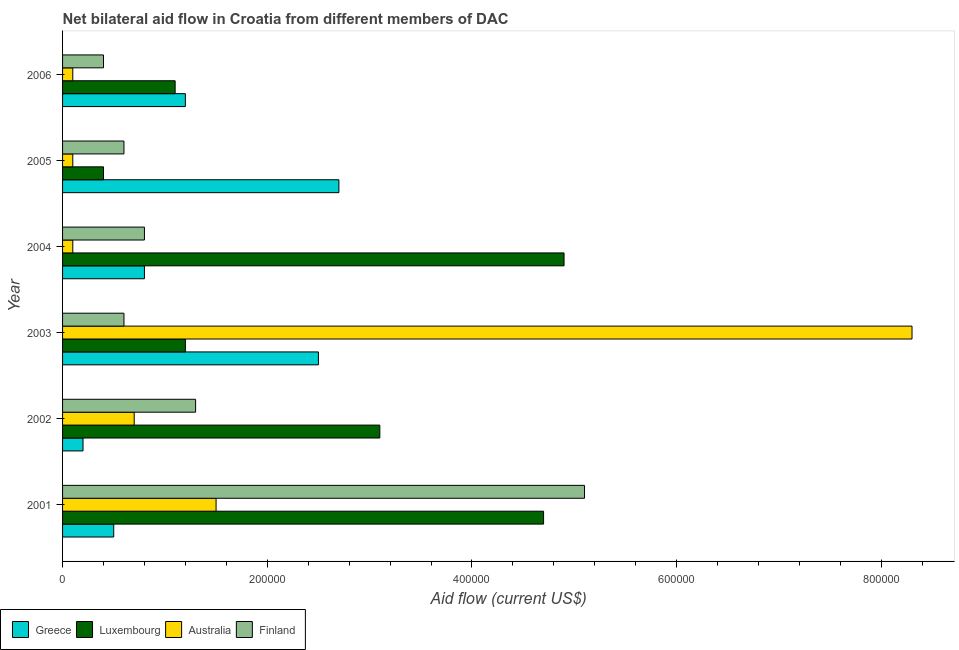Are the number of bars per tick equal to the number of legend labels?
Keep it short and to the point. Yes. Are the number of bars on each tick of the Y-axis equal?
Your answer should be very brief. Yes. How many bars are there on the 3rd tick from the top?
Give a very brief answer. 4. How many bars are there on the 5th tick from the bottom?
Your response must be concise. 4. What is the label of the 6th group of bars from the top?
Your answer should be compact. 2001. In how many cases, is the number of bars for a given year not equal to the number of legend labels?
Make the answer very short. 0. What is the amount of aid given by greece in 2005?
Ensure brevity in your answer.  2.70e+05. Across all years, what is the maximum amount of aid given by australia?
Give a very brief answer. 8.30e+05. Across all years, what is the minimum amount of aid given by australia?
Give a very brief answer. 10000. In which year was the amount of aid given by australia minimum?
Ensure brevity in your answer.  2004. What is the total amount of aid given by finland in the graph?
Your response must be concise. 8.80e+05. What is the difference between the amount of aid given by luxembourg in 2001 and that in 2005?
Provide a succinct answer. 4.30e+05. What is the average amount of aid given by greece per year?
Provide a succinct answer. 1.32e+05. In the year 2003, what is the difference between the amount of aid given by greece and amount of aid given by australia?
Provide a succinct answer. -5.80e+05. Is the difference between the amount of aid given by australia in 2003 and 2004 greater than the difference between the amount of aid given by finland in 2003 and 2004?
Provide a short and direct response. Yes. What is the difference between the highest and the second highest amount of aid given by finland?
Your response must be concise. 3.80e+05. What is the difference between the highest and the lowest amount of aid given by australia?
Provide a succinct answer. 8.20e+05. In how many years, is the amount of aid given by greece greater than the average amount of aid given by greece taken over all years?
Your answer should be compact. 2. Is it the case that in every year, the sum of the amount of aid given by australia and amount of aid given by greece is greater than the sum of amount of aid given by luxembourg and amount of aid given by finland?
Give a very brief answer. No. What does the 4th bar from the bottom in 2006 represents?
Keep it short and to the point. Finland. Is it the case that in every year, the sum of the amount of aid given by greece and amount of aid given by luxembourg is greater than the amount of aid given by australia?
Make the answer very short. No. How many years are there in the graph?
Offer a very short reply. 6. Does the graph contain any zero values?
Keep it short and to the point. No. Does the graph contain grids?
Your answer should be compact. No. How are the legend labels stacked?
Provide a short and direct response. Horizontal. What is the title of the graph?
Provide a short and direct response. Net bilateral aid flow in Croatia from different members of DAC. Does "Other greenhouse gases" appear as one of the legend labels in the graph?
Your response must be concise. No. What is the label or title of the X-axis?
Provide a short and direct response. Aid flow (current US$). What is the Aid flow (current US$) in Greece in 2001?
Give a very brief answer. 5.00e+04. What is the Aid flow (current US$) of Luxembourg in 2001?
Your answer should be very brief. 4.70e+05. What is the Aid flow (current US$) in Finland in 2001?
Your response must be concise. 5.10e+05. What is the Aid flow (current US$) in Greece in 2002?
Your answer should be very brief. 2.00e+04. What is the Aid flow (current US$) of Luxembourg in 2002?
Your answer should be very brief. 3.10e+05. What is the Aid flow (current US$) of Greece in 2003?
Keep it short and to the point. 2.50e+05. What is the Aid flow (current US$) of Luxembourg in 2003?
Offer a terse response. 1.20e+05. What is the Aid flow (current US$) in Australia in 2003?
Give a very brief answer. 8.30e+05. What is the Aid flow (current US$) of Finland in 2003?
Your answer should be very brief. 6.00e+04. What is the Aid flow (current US$) in Australia in 2004?
Provide a short and direct response. 10000. What is the Aid flow (current US$) in Greece in 2005?
Your response must be concise. 2.70e+05. What is the Aid flow (current US$) of Australia in 2005?
Offer a terse response. 10000. What is the Aid flow (current US$) of Greece in 2006?
Your response must be concise. 1.20e+05. What is the Aid flow (current US$) in Luxembourg in 2006?
Your response must be concise. 1.10e+05. Across all years, what is the maximum Aid flow (current US$) of Australia?
Make the answer very short. 8.30e+05. Across all years, what is the maximum Aid flow (current US$) of Finland?
Ensure brevity in your answer.  5.10e+05. Across all years, what is the minimum Aid flow (current US$) in Greece?
Your answer should be very brief. 2.00e+04. Across all years, what is the minimum Aid flow (current US$) of Luxembourg?
Your answer should be compact. 4.00e+04. Across all years, what is the minimum Aid flow (current US$) of Finland?
Your answer should be very brief. 4.00e+04. What is the total Aid flow (current US$) in Greece in the graph?
Give a very brief answer. 7.90e+05. What is the total Aid flow (current US$) of Luxembourg in the graph?
Make the answer very short. 1.54e+06. What is the total Aid flow (current US$) in Australia in the graph?
Offer a terse response. 1.08e+06. What is the total Aid flow (current US$) in Finland in the graph?
Provide a succinct answer. 8.80e+05. What is the difference between the Aid flow (current US$) of Finland in 2001 and that in 2002?
Keep it short and to the point. 3.80e+05. What is the difference between the Aid flow (current US$) in Greece in 2001 and that in 2003?
Your answer should be very brief. -2.00e+05. What is the difference between the Aid flow (current US$) of Australia in 2001 and that in 2003?
Provide a succinct answer. -6.80e+05. What is the difference between the Aid flow (current US$) of Greece in 2001 and that in 2004?
Keep it short and to the point. -3.00e+04. What is the difference between the Aid flow (current US$) of Luxembourg in 2001 and that in 2004?
Ensure brevity in your answer.  -2.00e+04. What is the difference between the Aid flow (current US$) in Finland in 2001 and that in 2004?
Provide a succinct answer. 4.30e+05. What is the difference between the Aid flow (current US$) in Greece in 2001 and that in 2005?
Your answer should be very brief. -2.20e+05. What is the difference between the Aid flow (current US$) of Luxembourg in 2001 and that in 2006?
Offer a terse response. 3.60e+05. What is the difference between the Aid flow (current US$) of Australia in 2001 and that in 2006?
Make the answer very short. 1.40e+05. What is the difference between the Aid flow (current US$) in Finland in 2001 and that in 2006?
Provide a short and direct response. 4.70e+05. What is the difference between the Aid flow (current US$) of Australia in 2002 and that in 2003?
Provide a succinct answer. -7.60e+05. What is the difference between the Aid flow (current US$) in Finland in 2002 and that in 2003?
Offer a very short reply. 7.00e+04. What is the difference between the Aid flow (current US$) of Greece in 2002 and that in 2004?
Offer a very short reply. -6.00e+04. What is the difference between the Aid flow (current US$) of Luxembourg in 2002 and that in 2004?
Your answer should be compact. -1.80e+05. What is the difference between the Aid flow (current US$) in Australia in 2002 and that in 2004?
Your answer should be very brief. 6.00e+04. What is the difference between the Aid flow (current US$) of Finland in 2002 and that in 2004?
Offer a very short reply. 5.00e+04. What is the difference between the Aid flow (current US$) of Greece in 2002 and that in 2005?
Offer a very short reply. -2.50e+05. What is the difference between the Aid flow (current US$) in Luxembourg in 2002 and that in 2005?
Keep it short and to the point. 2.70e+05. What is the difference between the Aid flow (current US$) of Australia in 2002 and that in 2005?
Ensure brevity in your answer.  6.00e+04. What is the difference between the Aid flow (current US$) in Finland in 2002 and that in 2005?
Your answer should be compact. 7.00e+04. What is the difference between the Aid flow (current US$) in Finland in 2002 and that in 2006?
Ensure brevity in your answer.  9.00e+04. What is the difference between the Aid flow (current US$) in Luxembourg in 2003 and that in 2004?
Give a very brief answer. -3.70e+05. What is the difference between the Aid flow (current US$) in Australia in 2003 and that in 2004?
Keep it short and to the point. 8.20e+05. What is the difference between the Aid flow (current US$) in Greece in 2003 and that in 2005?
Make the answer very short. -2.00e+04. What is the difference between the Aid flow (current US$) of Australia in 2003 and that in 2005?
Provide a succinct answer. 8.20e+05. What is the difference between the Aid flow (current US$) of Australia in 2003 and that in 2006?
Offer a terse response. 8.20e+05. What is the difference between the Aid flow (current US$) of Finland in 2003 and that in 2006?
Keep it short and to the point. 2.00e+04. What is the difference between the Aid flow (current US$) of Australia in 2004 and that in 2005?
Your answer should be very brief. 0. What is the difference between the Aid flow (current US$) of Finland in 2004 and that in 2006?
Your answer should be compact. 4.00e+04. What is the difference between the Aid flow (current US$) in Greece in 2005 and that in 2006?
Offer a terse response. 1.50e+05. What is the difference between the Aid flow (current US$) in Finland in 2005 and that in 2006?
Give a very brief answer. 2.00e+04. What is the difference between the Aid flow (current US$) of Greece in 2001 and the Aid flow (current US$) of Luxembourg in 2002?
Provide a short and direct response. -2.60e+05. What is the difference between the Aid flow (current US$) of Greece in 2001 and the Aid flow (current US$) of Australia in 2002?
Keep it short and to the point. -2.00e+04. What is the difference between the Aid flow (current US$) in Greece in 2001 and the Aid flow (current US$) in Finland in 2002?
Offer a terse response. -8.00e+04. What is the difference between the Aid flow (current US$) of Luxembourg in 2001 and the Aid flow (current US$) of Australia in 2002?
Ensure brevity in your answer.  4.00e+05. What is the difference between the Aid flow (current US$) in Greece in 2001 and the Aid flow (current US$) in Luxembourg in 2003?
Keep it short and to the point. -7.00e+04. What is the difference between the Aid flow (current US$) in Greece in 2001 and the Aid flow (current US$) in Australia in 2003?
Offer a terse response. -7.80e+05. What is the difference between the Aid flow (current US$) of Luxembourg in 2001 and the Aid flow (current US$) of Australia in 2003?
Keep it short and to the point. -3.60e+05. What is the difference between the Aid flow (current US$) of Luxembourg in 2001 and the Aid flow (current US$) of Finland in 2003?
Give a very brief answer. 4.10e+05. What is the difference between the Aid flow (current US$) of Greece in 2001 and the Aid flow (current US$) of Luxembourg in 2004?
Offer a very short reply. -4.40e+05. What is the difference between the Aid flow (current US$) in Luxembourg in 2001 and the Aid flow (current US$) in Australia in 2004?
Your response must be concise. 4.60e+05. What is the difference between the Aid flow (current US$) in Greece in 2001 and the Aid flow (current US$) in Finland in 2005?
Offer a very short reply. -10000. What is the difference between the Aid flow (current US$) in Australia in 2001 and the Aid flow (current US$) in Finland in 2005?
Provide a succinct answer. 9.00e+04. What is the difference between the Aid flow (current US$) of Luxembourg in 2001 and the Aid flow (current US$) of Australia in 2006?
Provide a succinct answer. 4.60e+05. What is the difference between the Aid flow (current US$) in Australia in 2001 and the Aid flow (current US$) in Finland in 2006?
Keep it short and to the point. 1.10e+05. What is the difference between the Aid flow (current US$) of Greece in 2002 and the Aid flow (current US$) of Australia in 2003?
Ensure brevity in your answer.  -8.10e+05. What is the difference between the Aid flow (current US$) in Luxembourg in 2002 and the Aid flow (current US$) in Australia in 2003?
Give a very brief answer. -5.20e+05. What is the difference between the Aid flow (current US$) of Luxembourg in 2002 and the Aid flow (current US$) of Finland in 2003?
Offer a terse response. 2.50e+05. What is the difference between the Aid flow (current US$) in Australia in 2002 and the Aid flow (current US$) in Finland in 2003?
Your response must be concise. 10000. What is the difference between the Aid flow (current US$) in Greece in 2002 and the Aid flow (current US$) in Luxembourg in 2004?
Your answer should be very brief. -4.70e+05. What is the difference between the Aid flow (current US$) in Luxembourg in 2002 and the Aid flow (current US$) in Australia in 2004?
Give a very brief answer. 3.00e+05. What is the difference between the Aid flow (current US$) of Luxembourg in 2002 and the Aid flow (current US$) of Finland in 2004?
Your answer should be very brief. 2.30e+05. What is the difference between the Aid flow (current US$) in Luxembourg in 2002 and the Aid flow (current US$) in Australia in 2005?
Your answer should be very brief. 3.00e+05. What is the difference between the Aid flow (current US$) of Luxembourg in 2002 and the Aid flow (current US$) of Finland in 2005?
Your response must be concise. 2.50e+05. What is the difference between the Aid flow (current US$) of Greece in 2002 and the Aid flow (current US$) of Australia in 2006?
Provide a succinct answer. 10000. What is the difference between the Aid flow (current US$) in Greece in 2002 and the Aid flow (current US$) in Finland in 2006?
Your answer should be compact. -2.00e+04. What is the difference between the Aid flow (current US$) of Greece in 2003 and the Aid flow (current US$) of Luxembourg in 2004?
Give a very brief answer. -2.40e+05. What is the difference between the Aid flow (current US$) in Luxembourg in 2003 and the Aid flow (current US$) in Australia in 2004?
Your answer should be compact. 1.10e+05. What is the difference between the Aid flow (current US$) in Australia in 2003 and the Aid flow (current US$) in Finland in 2004?
Provide a short and direct response. 7.50e+05. What is the difference between the Aid flow (current US$) in Greece in 2003 and the Aid flow (current US$) in Luxembourg in 2005?
Ensure brevity in your answer.  2.10e+05. What is the difference between the Aid flow (current US$) in Greece in 2003 and the Aid flow (current US$) in Finland in 2005?
Keep it short and to the point. 1.90e+05. What is the difference between the Aid flow (current US$) of Luxembourg in 2003 and the Aid flow (current US$) of Finland in 2005?
Give a very brief answer. 6.00e+04. What is the difference between the Aid flow (current US$) of Australia in 2003 and the Aid flow (current US$) of Finland in 2005?
Give a very brief answer. 7.70e+05. What is the difference between the Aid flow (current US$) in Greece in 2003 and the Aid flow (current US$) in Luxembourg in 2006?
Ensure brevity in your answer.  1.40e+05. What is the difference between the Aid flow (current US$) of Greece in 2003 and the Aid flow (current US$) of Australia in 2006?
Ensure brevity in your answer.  2.40e+05. What is the difference between the Aid flow (current US$) of Luxembourg in 2003 and the Aid flow (current US$) of Australia in 2006?
Ensure brevity in your answer.  1.10e+05. What is the difference between the Aid flow (current US$) in Luxembourg in 2003 and the Aid flow (current US$) in Finland in 2006?
Keep it short and to the point. 8.00e+04. What is the difference between the Aid flow (current US$) of Australia in 2003 and the Aid flow (current US$) of Finland in 2006?
Provide a short and direct response. 7.90e+05. What is the difference between the Aid flow (current US$) of Greece in 2004 and the Aid flow (current US$) of Luxembourg in 2005?
Your response must be concise. 4.00e+04. What is the difference between the Aid flow (current US$) in Greece in 2004 and the Aid flow (current US$) in Australia in 2005?
Keep it short and to the point. 7.00e+04. What is the difference between the Aid flow (current US$) of Greece in 2004 and the Aid flow (current US$) of Finland in 2005?
Give a very brief answer. 2.00e+04. What is the difference between the Aid flow (current US$) of Luxembourg in 2004 and the Aid flow (current US$) of Australia in 2005?
Keep it short and to the point. 4.80e+05. What is the difference between the Aid flow (current US$) of Greece in 2004 and the Aid flow (current US$) of Luxembourg in 2006?
Your answer should be compact. -3.00e+04. What is the difference between the Aid flow (current US$) in Greece in 2004 and the Aid flow (current US$) in Australia in 2006?
Offer a very short reply. 7.00e+04. What is the difference between the Aid flow (current US$) of Luxembourg in 2004 and the Aid flow (current US$) of Finland in 2006?
Offer a very short reply. 4.50e+05. What is the difference between the Aid flow (current US$) of Australia in 2004 and the Aid flow (current US$) of Finland in 2006?
Offer a very short reply. -3.00e+04. What is the difference between the Aid flow (current US$) of Greece in 2005 and the Aid flow (current US$) of Australia in 2006?
Provide a succinct answer. 2.60e+05. What is the difference between the Aid flow (current US$) in Luxembourg in 2005 and the Aid flow (current US$) in Australia in 2006?
Keep it short and to the point. 3.00e+04. What is the average Aid flow (current US$) of Greece per year?
Your answer should be compact. 1.32e+05. What is the average Aid flow (current US$) in Luxembourg per year?
Offer a terse response. 2.57e+05. What is the average Aid flow (current US$) in Australia per year?
Your response must be concise. 1.80e+05. What is the average Aid flow (current US$) of Finland per year?
Keep it short and to the point. 1.47e+05. In the year 2001, what is the difference between the Aid flow (current US$) of Greece and Aid flow (current US$) of Luxembourg?
Keep it short and to the point. -4.20e+05. In the year 2001, what is the difference between the Aid flow (current US$) of Greece and Aid flow (current US$) of Australia?
Your answer should be compact. -1.00e+05. In the year 2001, what is the difference between the Aid flow (current US$) in Greece and Aid flow (current US$) in Finland?
Provide a succinct answer. -4.60e+05. In the year 2001, what is the difference between the Aid flow (current US$) of Luxembourg and Aid flow (current US$) of Australia?
Your answer should be very brief. 3.20e+05. In the year 2001, what is the difference between the Aid flow (current US$) of Luxembourg and Aid flow (current US$) of Finland?
Ensure brevity in your answer.  -4.00e+04. In the year 2001, what is the difference between the Aid flow (current US$) in Australia and Aid flow (current US$) in Finland?
Provide a short and direct response. -3.60e+05. In the year 2002, what is the difference between the Aid flow (current US$) of Greece and Aid flow (current US$) of Australia?
Offer a very short reply. -5.00e+04. In the year 2002, what is the difference between the Aid flow (current US$) in Luxembourg and Aid flow (current US$) in Australia?
Provide a succinct answer. 2.40e+05. In the year 2003, what is the difference between the Aid flow (current US$) in Greece and Aid flow (current US$) in Luxembourg?
Your answer should be very brief. 1.30e+05. In the year 2003, what is the difference between the Aid flow (current US$) of Greece and Aid flow (current US$) of Australia?
Offer a very short reply. -5.80e+05. In the year 2003, what is the difference between the Aid flow (current US$) in Luxembourg and Aid flow (current US$) in Australia?
Provide a short and direct response. -7.10e+05. In the year 2003, what is the difference between the Aid flow (current US$) in Australia and Aid flow (current US$) in Finland?
Your answer should be compact. 7.70e+05. In the year 2004, what is the difference between the Aid flow (current US$) of Greece and Aid flow (current US$) of Luxembourg?
Your response must be concise. -4.10e+05. In the year 2004, what is the difference between the Aid flow (current US$) of Greece and Aid flow (current US$) of Australia?
Ensure brevity in your answer.  7.00e+04. In the year 2004, what is the difference between the Aid flow (current US$) in Greece and Aid flow (current US$) in Finland?
Provide a succinct answer. 0. In the year 2004, what is the difference between the Aid flow (current US$) in Luxembourg and Aid flow (current US$) in Finland?
Your answer should be compact. 4.10e+05. In the year 2004, what is the difference between the Aid flow (current US$) of Australia and Aid flow (current US$) of Finland?
Ensure brevity in your answer.  -7.00e+04. In the year 2005, what is the difference between the Aid flow (current US$) in Greece and Aid flow (current US$) in Luxembourg?
Give a very brief answer. 2.30e+05. In the year 2005, what is the difference between the Aid flow (current US$) in Greece and Aid flow (current US$) in Australia?
Make the answer very short. 2.60e+05. In the year 2005, what is the difference between the Aid flow (current US$) of Greece and Aid flow (current US$) of Finland?
Your answer should be very brief. 2.10e+05. In the year 2005, what is the difference between the Aid flow (current US$) of Luxembourg and Aid flow (current US$) of Australia?
Your answer should be very brief. 3.00e+04. In the year 2005, what is the difference between the Aid flow (current US$) of Australia and Aid flow (current US$) of Finland?
Keep it short and to the point. -5.00e+04. In the year 2006, what is the difference between the Aid flow (current US$) of Greece and Aid flow (current US$) of Australia?
Offer a very short reply. 1.10e+05. In the year 2006, what is the difference between the Aid flow (current US$) in Greece and Aid flow (current US$) in Finland?
Offer a terse response. 8.00e+04. In the year 2006, what is the difference between the Aid flow (current US$) of Luxembourg and Aid flow (current US$) of Australia?
Give a very brief answer. 1.00e+05. In the year 2006, what is the difference between the Aid flow (current US$) in Luxembourg and Aid flow (current US$) in Finland?
Make the answer very short. 7.00e+04. What is the ratio of the Aid flow (current US$) in Greece in 2001 to that in 2002?
Provide a succinct answer. 2.5. What is the ratio of the Aid flow (current US$) in Luxembourg in 2001 to that in 2002?
Your response must be concise. 1.52. What is the ratio of the Aid flow (current US$) in Australia in 2001 to that in 2002?
Your answer should be very brief. 2.14. What is the ratio of the Aid flow (current US$) of Finland in 2001 to that in 2002?
Give a very brief answer. 3.92. What is the ratio of the Aid flow (current US$) in Luxembourg in 2001 to that in 2003?
Offer a terse response. 3.92. What is the ratio of the Aid flow (current US$) of Australia in 2001 to that in 2003?
Offer a terse response. 0.18. What is the ratio of the Aid flow (current US$) of Greece in 2001 to that in 2004?
Your answer should be very brief. 0.62. What is the ratio of the Aid flow (current US$) in Luxembourg in 2001 to that in 2004?
Make the answer very short. 0.96. What is the ratio of the Aid flow (current US$) in Australia in 2001 to that in 2004?
Ensure brevity in your answer.  15. What is the ratio of the Aid flow (current US$) in Finland in 2001 to that in 2004?
Provide a short and direct response. 6.38. What is the ratio of the Aid flow (current US$) in Greece in 2001 to that in 2005?
Offer a terse response. 0.19. What is the ratio of the Aid flow (current US$) of Luxembourg in 2001 to that in 2005?
Provide a succinct answer. 11.75. What is the ratio of the Aid flow (current US$) in Australia in 2001 to that in 2005?
Your response must be concise. 15. What is the ratio of the Aid flow (current US$) of Greece in 2001 to that in 2006?
Give a very brief answer. 0.42. What is the ratio of the Aid flow (current US$) of Luxembourg in 2001 to that in 2006?
Your answer should be very brief. 4.27. What is the ratio of the Aid flow (current US$) of Australia in 2001 to that in 2006?
Your answer should be compact. 15. What is the ratio of the Aid flow (current US$) of Finland in 2001 to that in 2006?
Your response must be concise. 12.75. What is the ratio of the Aid flow (current US$) in Luxembourg in 2002 to that in 2003?
Make the answer very short. 2.58. What is the ratio of the Aid flow (current US$) of Australia in 2002 to that in 2003?
Give a very brief answer. 0.08. What is the ratio of the Aid flow (current US$) in Finland in 2002 to that in 2003?
Make the answer very short. 2.17. What is the ratio of the Aid flow (current US$) of Luxembourg in 2002 to that in 2004?
Offer a terse response. 0.63. What is the ratio of the Aid flow (current US$) of Finland in 2002 to that in 2004?
Your answer should be very brief. 1.62. What is the ratio of the Aid flow (current US$) in Greece in 2002 to that in 2005?
Your response must be concise. 0.07. What is the ratio of the Aid flow (current US$) of Luxembourg in 2002 to that in 2005?
Offer a terse response. 7.75. What is the ratio of the Aid flow (current US$) of Australia in 2002 to that in 2005?
Your response must be concise. 7. What is the ratio of the Aid flow (current US$) of Finland in 2002 to that in 2005?
Offer a very short reply. 2.17. What is the ratio of the Aid flow (current US$) in Greece in 2002 to that in 2006?
Make the answer very short. 0.17. What is the ratio of the Aid flow (current US$) of Luxembourg in 2002 to that in 2006?
Your response must be concise. 2.82. What is the ratio of the Aid flow (current US$) in Australia in 2002 to that in 2006?
Ensure brevity in your answer.  7. What is the ratio of the Aid flow (current US$) of Greece in 2003 to that in 2004?
Your answer should be very brief. 3.12. What is the ratio of the Aid flow (current US$) of Luxembourg in 2003 to that in 2004?
Give a very brief answer. 0.24. What is the ratio of the Aid flow (current US$) in Finland in 2003 to that in 2004?
Your answer should be compact. 0.75. What is the ratio of the Aid flow (current US$) of Greece in 2003 to that in 2005?
Ensure brevity in your answer.  0.93. What is the ratio of the Aid flow (current US$) of Luxembourg in 2003 to that in 2005?
Give a very brief answer. 3. What is the ratio of the Aid flow (current US$) of Australia in 2003 to that in 2005?
Keep it short and to the point. 83. What is the ratio of the Aid flow (current US$) of Greece in 2003 to that in 2006?
Provide a succinct answer. 2.08. What is the ratio of the Aid flow (current US$) in Australia in 2003 to that in 2006?
Provide a short and direct response. 83. What is the ratio of the Aid flow (current US$) in Greece in 2004 to that in 2005?
Offer a terse response. 0.3. What is the ratio of the Aid flow (current US$) in Luxembourg in 2004 to that in 2005?
Provide a succinct answer. 12.25. What is the ratio of the Aid flow (current US$) of Australia in 2004 to that in 2005?
Your answer should be very brief. 1. What is the ratio of the Aid flow (current US$) of Greece in 2004 to that in 2006?
Provide a succinct answer. 0.67. What is the ratio of the Aid flow (current US$) of Luxembourg in 2004 to that in 2006?
Your answer should be very brief. 4.45. What is the ratio of the Aid flow (current US$) in Greece in 2005 to that in 2006?
Make the answer very short. 2.25. What is the ratio of the Aid flow (current US$) in Luxembourg in 2005 to that in 2006?
Your response must be concise. 0.36. What is the difference between the highest and the second highest Aid flow (current US$) in Australia?
Keep it short and to the point. 6.80e+05. What is the difference between the highest and the second highest Aid flow (current US$) of Finland?
Your answer should be compact. 3.80e+05. What is the difference between the highest and the lowest Aid flow (current US$) in Greece?
Provide a short and direct response. 2.50e+05. What is the difference between the highest and the lowest Aid flow (current US$) of Australia?
Ensure brevity in your answer.  8.20e+05. What is the difference between the highest and the lowest Aid flow (current US$) of Finland?
Make the answer very short. 4.70e+05. 